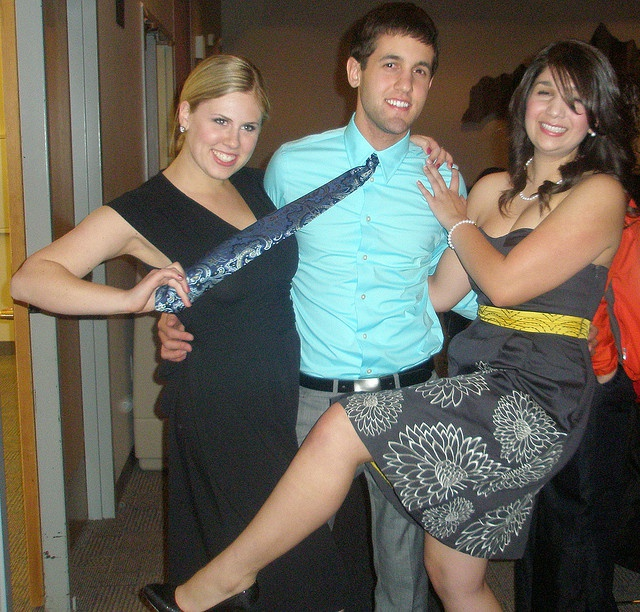Describe the objects in this image and their specific colors. I can see people in olive, gray, tan, and black tones, people in olive, black, and tan tones, people in olive, lightblue, gray, black, and turquoise tones, and tie in olive, gray, and blue tones in this image. 